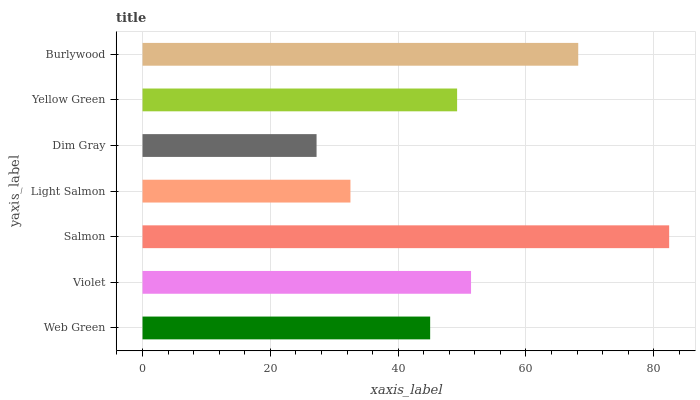Is Dim Gray the minimum?
Answer yes or no. Yes. Is Salmon the maximum?
Answer yes or no. Yes. Is Violet the minimum?
Answer yes or no. No. Is Violet the maximum?
Answer yes or no. No. Is Violet greater than Web Green?
Answer yes or no. Yes. Is Web Green less than Violet?
Answer yes or no. Yes. Is Web Green greater than Violet?
Answer yes or no. No. Is Violet less than Web Green?
Answer yes or no. No. Is Yellow Green the high median?
Answer yes or no. Yes. Is Yellow Green the low median?
Answer yes or no. Yes. Is Salmon the high median?
Answer yes or no. No. Is Salmon the low median?
Answer yes or no. No. 